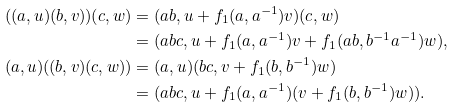<formula> <loc_0><loc_0><loc_500><loc_500>( ( a , u ) ( b , v ) ) ( c , w ) & = ( a b , u + f _ { 1 } ( a , a ^ { - 1 } ) v ) ( c , w ) \\ & = ( a b c , u + f _ { 1 } ( a , a ^ { - 1 } ) v + f _ { 1 } ( a b , b ^ { - 1 } a ^ { - 1 } ) w ) , \\ ( a , u ) ( ( b , v ) ( c , w ) ) & = ( a , u ) ( b c , v + f _ { 1 } ( b , b ^ { - 1 } ) w ) \\ & = ( a b c , u + f _ { 1 } ( a , a ^ { - 1 } ) ( v + f _ { 1 } ( b , b ^ { - 1 } ) w ) ) .</formula> 